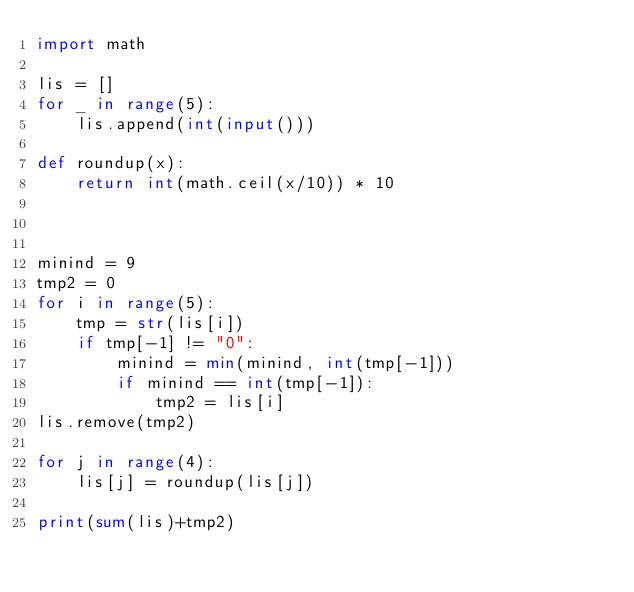<code> <loc_0><loc_0><loc_500><loc_500><_Python_>import math

lis = []
for _ in range(5):
    lis.append(int(input()))
    
def roundup(x):
    return int(math.ceil(x/10)) * 10
    

    
minind = 9
tmp2 = 0
for i in range(5):
    tmp = str(lis[i])
    if tmp[-1] != "0":
        minind = min(minind, int(tmp[-1]))
        if minind == int(tmp[-1]):
            tmp2 = lis[i]
lis.remove(tmp2)

for j in range(4):
    lis[j] = roundup(lis[j])
        
print(sum(lis)+tmp2)</code> 